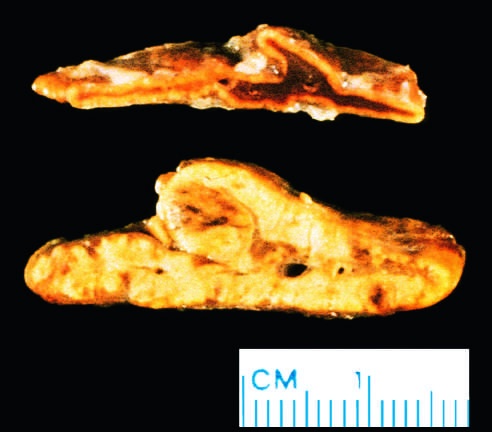were the thickened alveolar walls diffusely hyperplastic?
Answer the question using a single word or phrase. No 